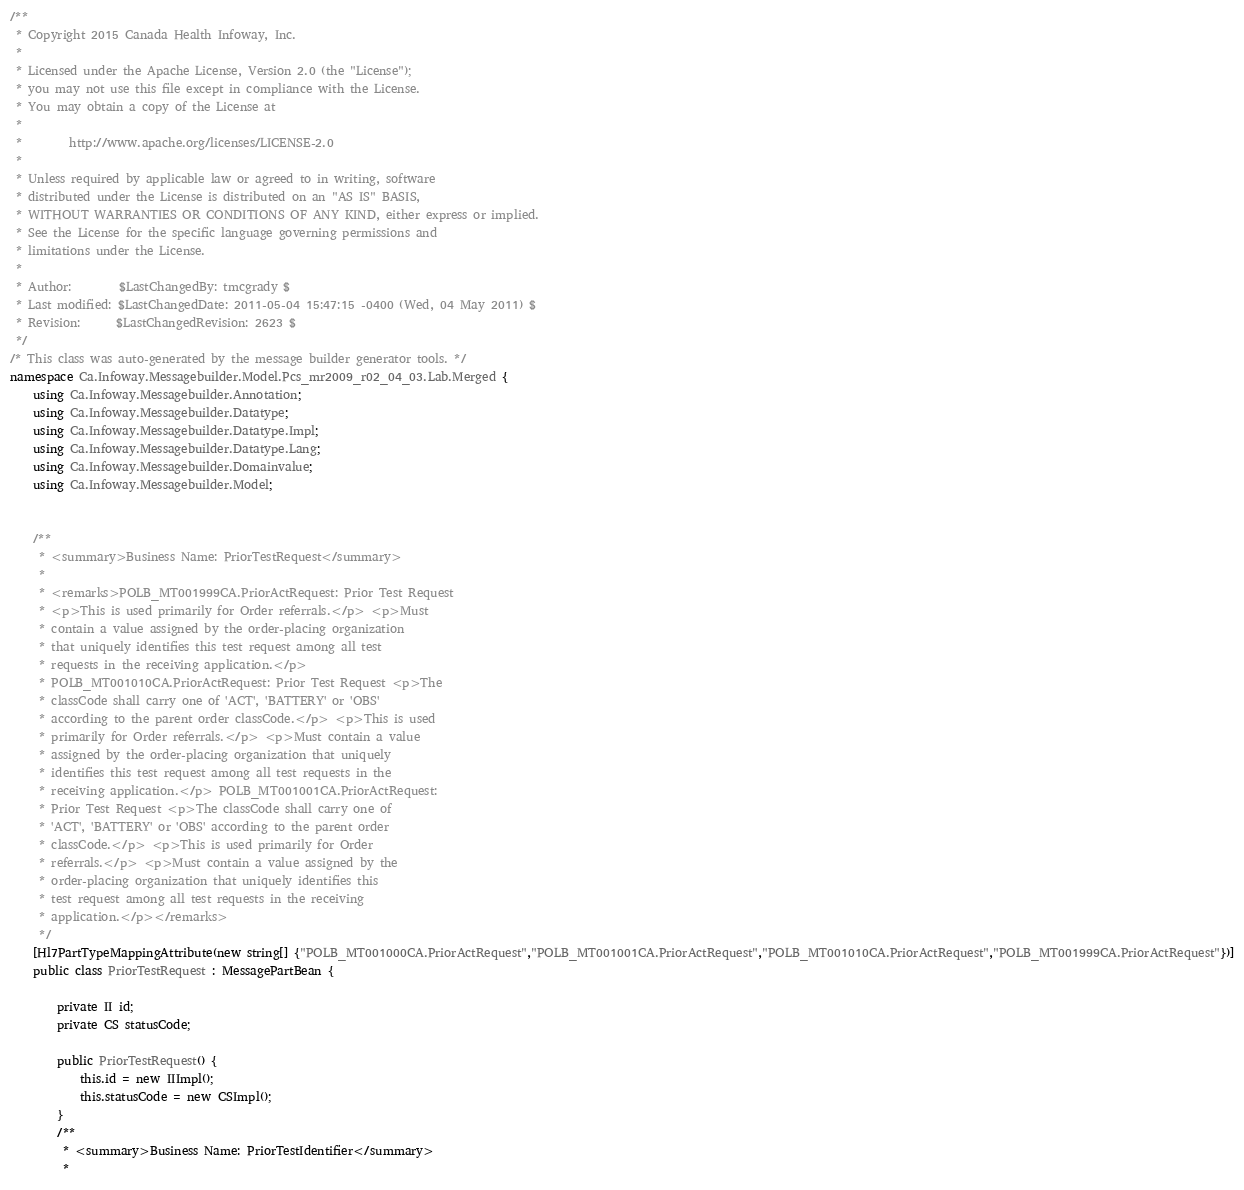<code> <loc_0><loc_0><loc_500><loc_500><_C#_>/**
 * Copyright 2015 Canada Health Infoway, Inc.
 *
 * Licensed under the Apache License, Version 2.0 (the "License");
 * you may not use this file except in compliance with the License.
 * You may obtain a copy of the License at
 *
 *        http://www.apache.org/licenses/LICENSE-2.0
 *
 * Unless required by applicable law or agreed to in writing, software
 * distributed under the License is distributed on an "AS IS" BASIS,
 * WITHOUT WARRANTIES OR CONDITIONS OF ANY KIND, either express or implied.
 * See the License for the specific language governing permissions and
 * limitations under the License.
 *
 * Author:        $LastChangedBy: tmcgrady $
 * Last modified: $LastChangedDate: 2011-05-04 15:47:15 -0400 (Wed, 04 May 2011) $
 * Revision:      $LastChangedRevision: 2623 $
 */
/* This class was auto-generated by the message builder generator tools. */
namespace Ca.Infoway.Messagebuilder.Model.Pcs_mr2009_r02_04_03.Lab.Merged {
    using Ca.Infoway.Messagebuilder.Annotation;
    using Ca.Infoway.Messagebuilder.Datatype;
    using Ca.Infoway.Messagebuilder.Datatype.Impl;
    using Ca.Infoway.Messagebuilder.Datatype.Lang;
    using Ca.Infoway.Messagebuilder.Domainvalue;
    using Ca.Infoway.Messagebuilder.Model;


    /**
     * <summary>Business Name: PriorTestRequest</summary>
     * 
     * <remarks>POLB_MT001999CA.PriorActRequest: Prior Test Request 
     * <p>This is used primarily for Order referrals.</p> <p>Must 
     * contain a value assigned by the order-placing organization 
     * that uniquely identifies this test request among all test 
     * requests in the receiving application.</p> 
     * POLB_MT001010CA.PriorActRequest: Prior Test Request <p>The 
     * classCode shall carry one of 'ACT', 'BATTERY' or 'OBS' 
     * according to the parent order classCode.</p> <p>This is used 
     * primarily for Order referrals.</p> <p>Must contain a value 
     * assigned by the order-placing organization that uniquely 
     * identifies this test request among all test requests in the 
     * receiving application.</p> POLB_MT001001CA.PriorActRequest: 
     * Prior Test Request <p>The classCode shall carry one of 
     * 'ACT', 'BATTERY' or 'OBS' according to the parent order 
     * classCode.</p> <p>This is used primarily for Order 
     * referrals.</p> <p>Must contain a value assigned by the 
     * order-placing organization that uniquely identifies this 
     * test request among all test requests in the receiving 
     * application.</p></remarks>
     */
    [Hl7PartTypeMappingAttribute(new string[] {"POLB_MT001000CA.PriorActRequest","POLB_MT001001CA.PriorActRequest","POLB_MT001010CA.PriorActRequest","POLB_MT001999CA.PriorActRequest"})]
    public class PriorTestRequest : MessagePartBean {

        private II id;
        private CS statusCode;

        public PriorTestRequest() {
            this.id = new IIImpl();
            this.statusCode = new CSImpl();
        }
        /**
         * <summary>Business Name: PriorTestIdentifier</summary>
         * </code> 